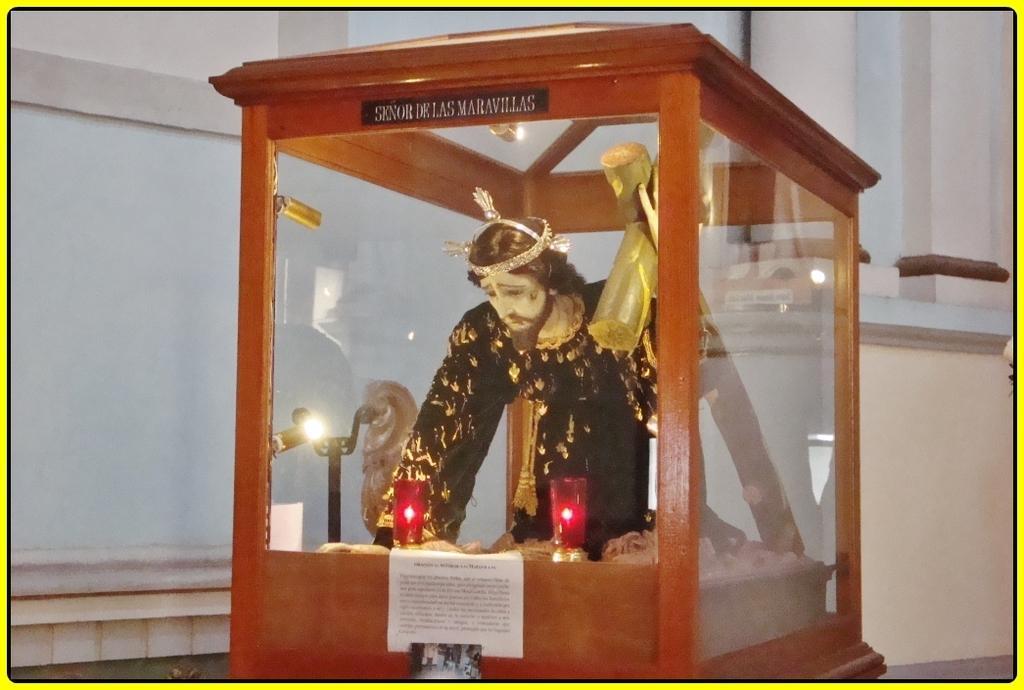Please provide a concise description of this image. This image is taken in a church. In the background there is a wall. In the middle of the image there is a box which is made of wood and glass. In the box there is a statue of Jesus and there are a few candles. 